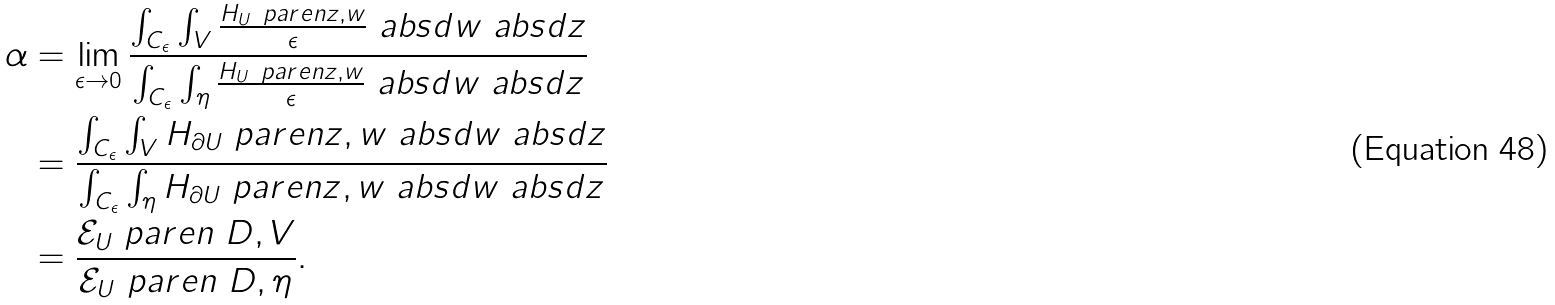Convert formula to latex. <formula><loc_0><loc_0><loc_500><loc_500>\alpha & = \lim _ { \epsilon \rightarrow 0 } \frac { \int _ { C _ { \epsilon } } \int _ { V } \frac { H _ { U } \ p a r e n { z , w } } { \epsilon } \ a b s { d w } \ a b s { d z } } { \int _ { C _ { \epsilon } } \int _ { \eta } \frac { H _ { U } \ p a r e n { z , w } } { \epsilon } \ a b s { d w } \ a b s { d z } } \\ & = \frac { \int _ { C _ { \epsilon } } \int _ { V } H _ { \partial U } \ p a r e n { z , w } \ a b s { d w } \ a b s { d z } } { \int _ { C _ { \epsilon } } \int _ { \eta } H _ { \partial U } \ p a r e n { z , w } \ a b s { d w } \ a b s { d z } } \\ & = \frac { \mathcal { E } _ { U } \ p a r e n { \ D , V } } { \mathcal { E } _ { U } \ p a r e n { \ D , \eta } } .</formula> 